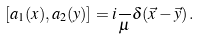Convert formula to latex. <formula><loc_0><loc_0><loc_500><loc_500>[ a _ { 1 } ( x ) , a _ { 2 } ( y ) ] = i { \frac { } { \mu } } \delta ( \vec { x } - \vec { y } ) \, .</formula> 